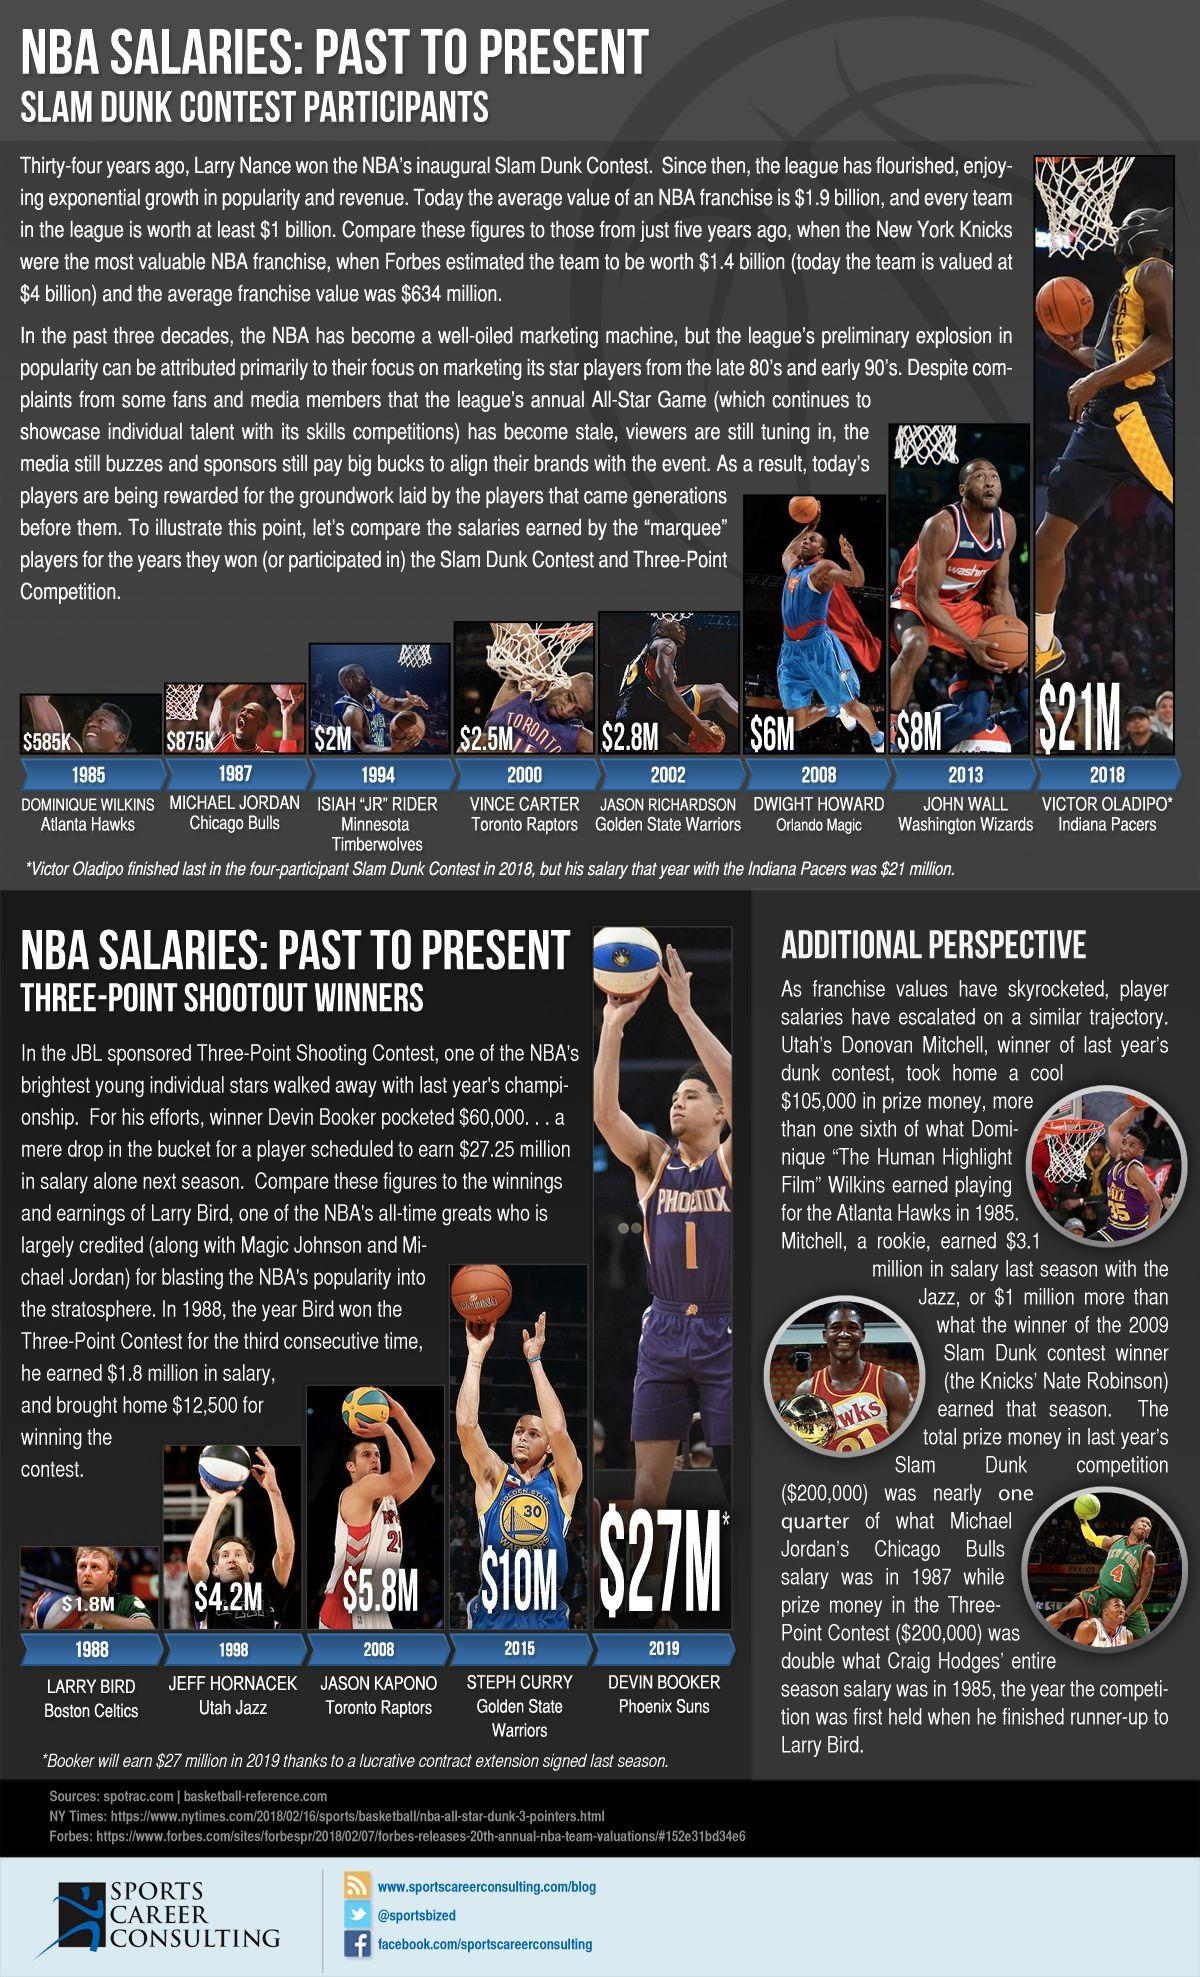List a handful of essential elements in this visual. It is a well-known fact that Michael Jordan was a member of the Chicago Bulls basketball team. In the NBA's Slam Dunk contest, Vince Carter received the prize money of $2.5M. The winner of the NBA's Slam Dunk Contest in 2000 is a member of the Toronto Raptors. It has been confirmed that Jason Richardson is currently a member of the Golden State Warriors team. Dwight Howard was the winner of the NBA's Slam Dunk Contest in 2008. 